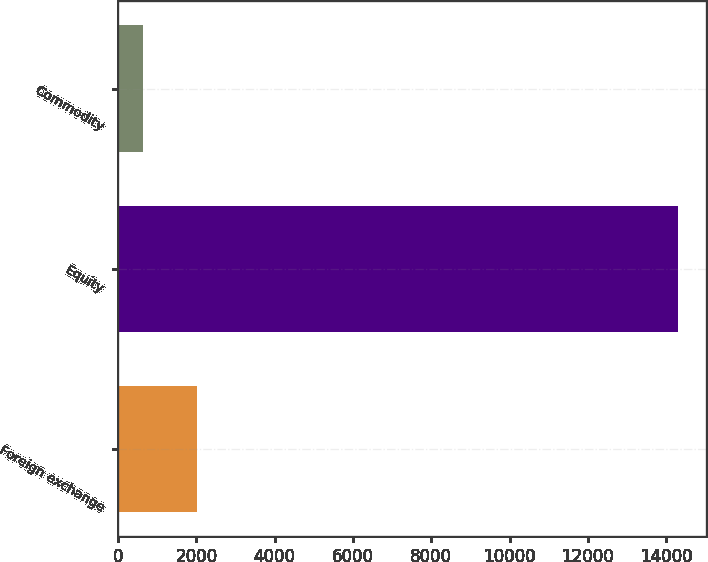<chart> <loc_0><loc_0><loc_500><loc_500><bar_chart><fcel>Foreign exchange<fcel>Equity<fcel>Commodity<nl><fcel>2005.3<fcel>14293<fcel>640<nl></chart> 